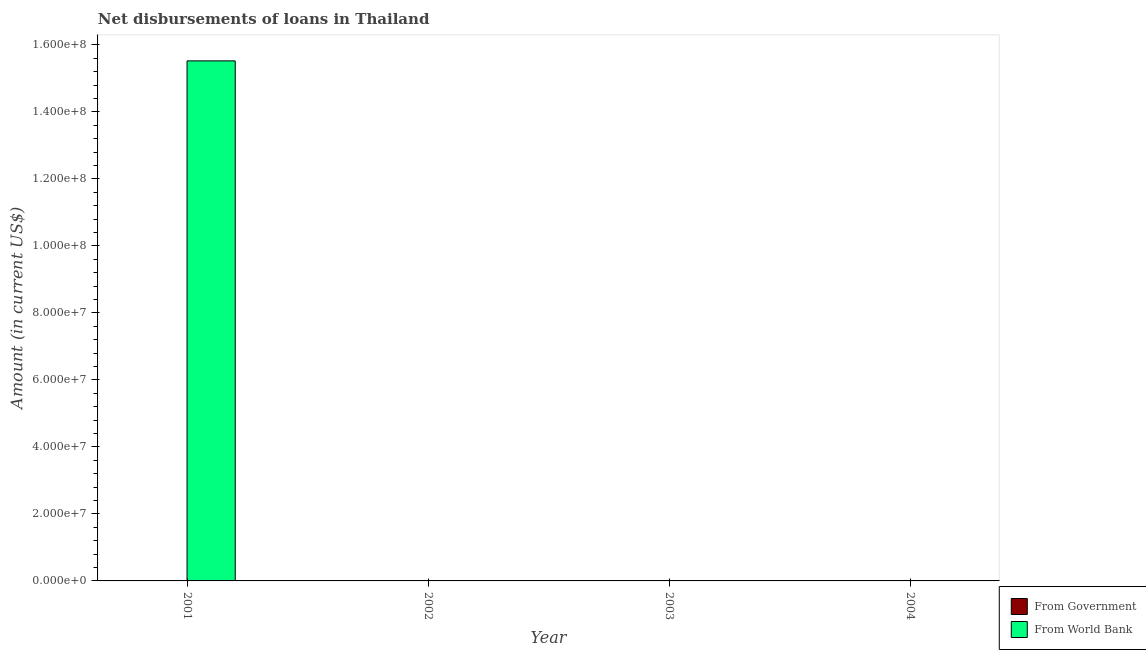How many different coloured bars are there?
Provide a short and direct response. 1. Are the number of bars per tick equal to the number of legend labels?
Offer a very short reply. No. Are the number of bars on each tick of the X-axis equal?
Give a very brief answer. No. How many bars are there on the 3rd tick from the right?
Give a very brief answer. 0. What is the label of the 1st group of bars from the left?
Provide a succinct answer. 2001. In how many cases, is the number of bars for a given year not equal to the number of legend labels?
Your answer should be very brief. 4. What is the net disbursements of loan from world bank in 2004?
Provide a succinct answer. 0. Across all years, what is the maximum net disbursements of loan from world bank?
Ensure brevity in your answer.  1.55e+08. In which year was the net disbursements of loan from world bank maximum?
Make the answer very short. 2001. What is the total net disbursements of loan from government in the graph?
Keep it short and to the point. 0. In how many years, is the net disbursements of loan from world bank greater than 92000000 US$?
Your answer should be compact. 1. What is the difference between the highest and the lowest net disbursements of loan from world bank?
Keep it short and to the point. 1.55e+08. In how many years, is the net disbursements of loan from world bank greater than the average net disbursements of loan from world bank taken over all years?
Keep it short and to the point. 1. Are all the bars in the graph horizontal?
Your answer should be very brief. No. What is the difference between two consecutive major ticks on the Y-axis?
Offer a terse response. 2.00e+07. Are the values on the major ticks of Y-axis written in scientific E-notation?
Your answer should be very brief. Yes. Does the graph contain grids?
Keep it short and to the point. No. Where does the legend appear in the graph?
Offer a very short reply. Bottom right. How many legend labels are there?
Give a very brief answer. 2. How are the legend labels stacked?
Offer a very short reply. Vertical. What is the title of the graph?
Keep it short and to the point. Net disbursements of loans in Thailand. Does "Tetanus" appear as one of the legend labels in the graph?
Keep it short and to the point. No. What is the label or title of the X-axis?
Ensure brevity in your answer.  Year. What is the label or title of the Y-axis?
Ensure brevity in your answer.  Amount (in current US$). What is the Amount (in current US$) of From Government in 2001?
Provide a short and direct response. 0. What is the Amount (in current US$) in From World Bank in 2001?
Provide a short and direct response. 1.55e+08. What is the Amount (in current US$) of From Government in 2002?
Your answer should be very brief. 0. What is the Amount (in current US$) in From World Bank in 2002?
Provide a succinct answer. 0. What is the Amount (in current US$) in From Government in 2003?
Provide a short and direct response. 0. What is the Amount (in current US$) of From World Bank in 2003?
Keep it short and to the point. 0. What is the Amount (in current US$) in From Government in 2004?
Provide a succinct answer. 0. Across all years, what is the maximum Amount (in current US$) of From World Bank?
Provide a short and direct response. 1.55e+08. Across all years, what is the minimum Amount (in current US$) of From World Bank?
Give a very brief answer. 0. What is the total Amount (in current US$) of From World Bank in the graph?
Provide a succinct answer. 1.55e+08. What is the average Amount (in current US$) of From World Bank per year?
Provide a succinct answer. 3.88e+07. What is the difference between the highest and the lowest Amount (in current US$) of From World Bank?
Your answer should be very brief. 1.55e+08. 